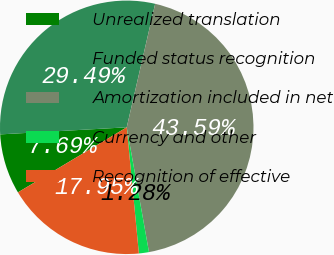<chart> <loc_0><loc_0><loc_500><loc_500><pie_chart><fcel>Unrealized translation<fcel>Funded status recognition<fcel>Amortization included in net<fcel>Currency and other<fcel>Recognition of effective<nl><fcel>7.69%<fcel>29.49%<fcel>43.59%<fcel>1.28%<fcel>17.95%<nl></chart> 